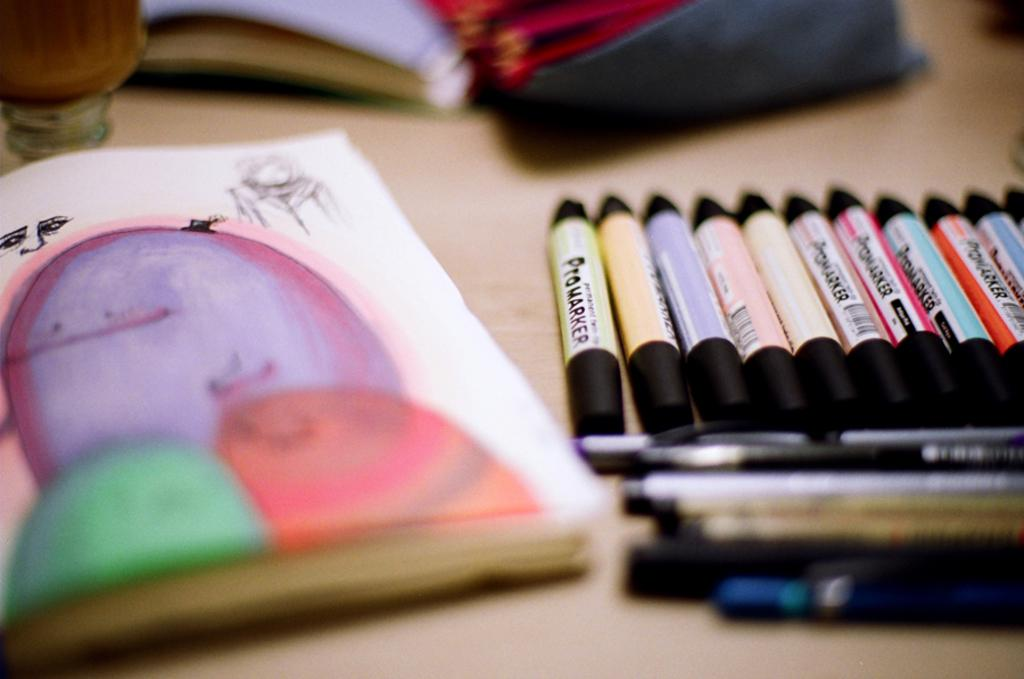<image>
Give a short and clear explanation of the subsequent image. A collection of markers next to an open sketchbook. 